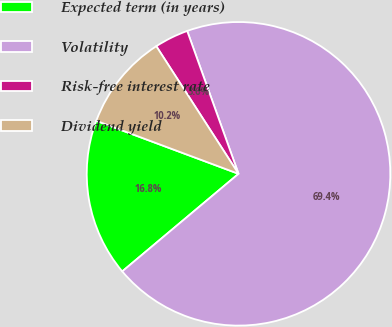<chart> <loc_0><loc_0><loc_500><loc_500><pie_chart><fcel>Expected term (in years)<fcel>Volatility<fcel>Risk-free interest rate<fcel>Dividend yield<nl><fcel>16.79%<fcel>69.38%<fcel>3.62%<fcel>10.21%<nl></chart> 